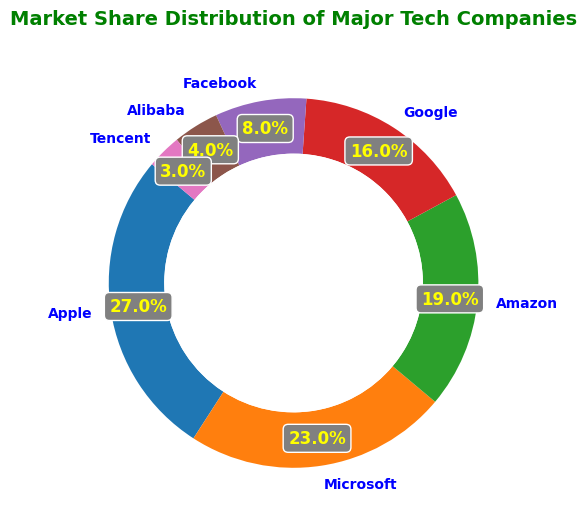Which company has the highest market share? Apple has the highest market share of 27%, which is displayed by the largest section of the ring chart.
Answer: Apple Which companies have a combined market share of over 40%? Apple and Microsoft together have a market share of 27% + 23% = 50%, which exceeds 40%.
Answer: Apple and Microsoft What is the difference in market share between Amazon and Google? Amazon has a market share of 19% while Google has a market share of 16%. The difference between them is 19% - 16% = 3%.
Answer: 3% What is the sum of the market shares of Facebook, Alibaba, and Tencent? Facebook, Alibaba, and Tencent have market shares of 8%, 4%, and 3% respectively. The sum is 8% + 4% + 3% = 15%.
Answer: 15% How does the market share of Microsoft compare to that of Google? Microsoft's market share is 23%, which is greater than Google's market share of 16%.
Answer: Microsoft's market share is greater than Google's Which company has the smallest market share, and what is it? Tencent has the smallest market share of 3%, which is the smallest section of the ring chart.
Answer: Tencent, 3% If the market share of Google doubles, will it surpass Apple's current market share? If Google's market share doubles, it will be 16% * 2 = 32%. This is greater than Apple's current market share of 27%.
Answer: Yes Which companies together hold more than 70% of the market share? Apple, Microsoft, and Amazon together have market shares of 27%, 23%, and 19% respectively. Their combined market share is 27% + 23% + 19% = 69%. Adding Google's 16% gives 85%, surpassing 70%. Therefore, Apple, Microsoft, Amazon, and Google together hold more than 70% of the market share.
Answer: Apple, Microsoft, Amazon, and Google 